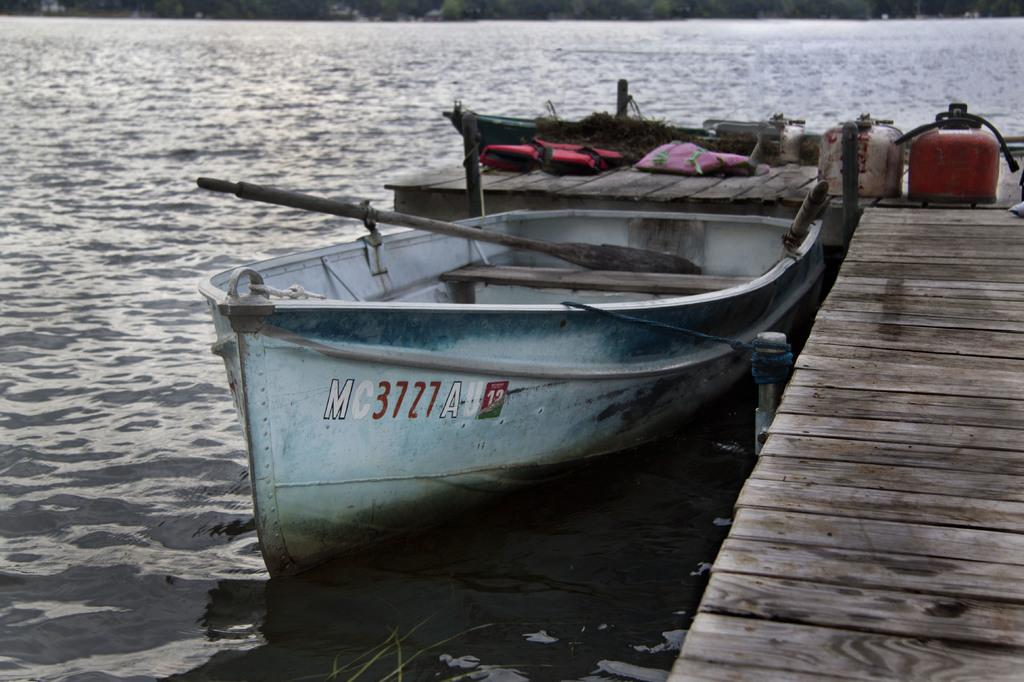What is the main subject of the image? The main subject of the image is a boat on the water surface. What can be seen in the foreground area of the image? There is a dock and cylinders in the foreground area of the image. What is visible in the background of the image? It appears that there are trees and water in the background of the image. Can you tell me who won the argument on the boat in the image? There is no argument depicted in the image; it only shows a boat on the water surface. What type of good-bye is being said by the trees in the background of the image? There is no good-bye being said by the trees or any other elements in the image. 